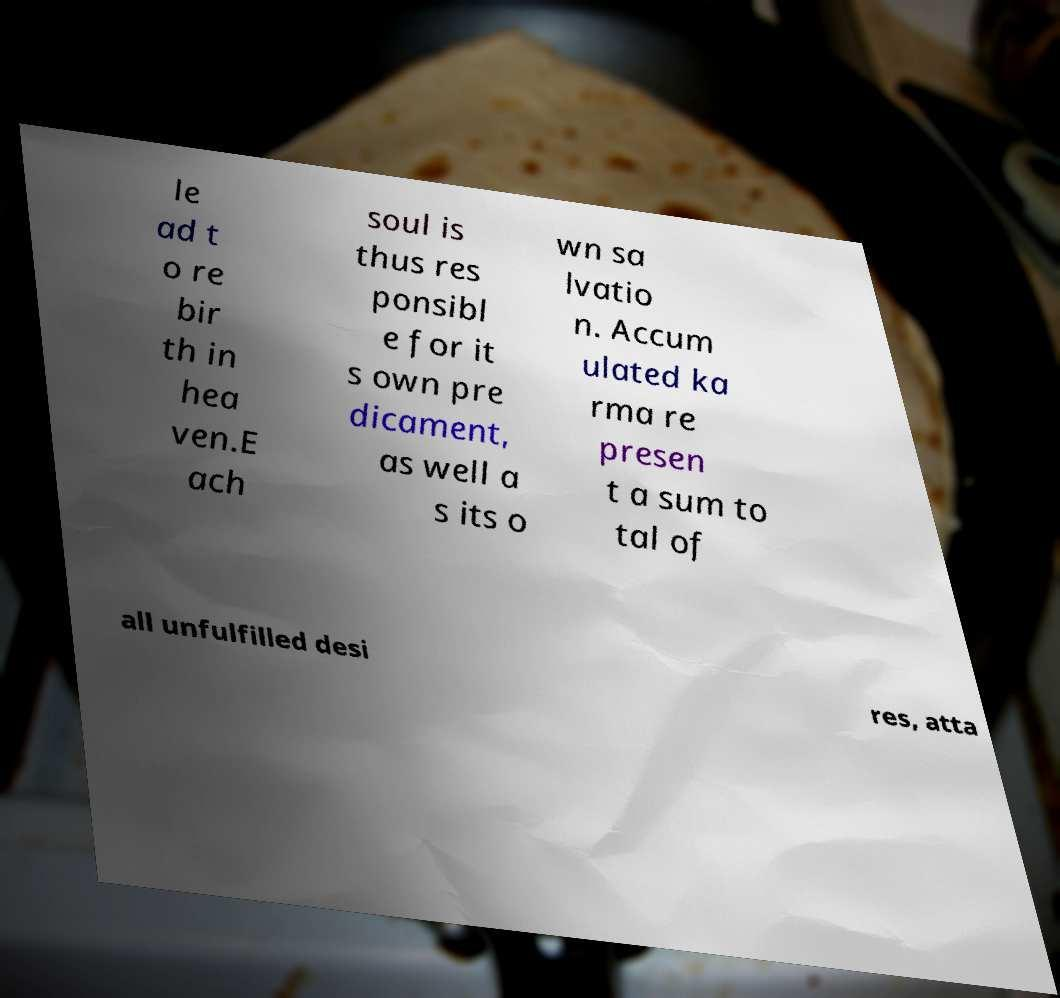Please identify and transcribe the text found in this image. le ad t o re bir th in hea ven.E ach soul is thus res ponsibl e for it s own pre dicament, as well a s its o wn sa lvatio n. Accum ulated ka rma re presen t a sum to tal of all unfulfilled desi res, atta 